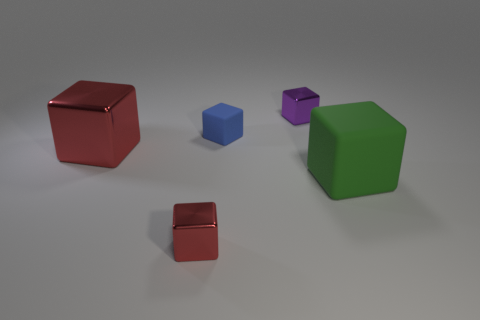Subtract all blue blocks. How many blocks are left? 4 Subtract all big green cubes. How many cubes are left? 4 Subtract all brown cubes. Subtract all yellow balls. How many cubes are left? 5 Add 3 tiny metal cubes. How many objects exist? 8 Add 4 blue matte things. How many blue matte things are left? 5 Add 3 small shiny cubes. How many small shiny cubes exist? 5 Subtract 0 green cylinders. How many objects are left? 5 Subtract all large red things. Subtract all small blue shiny objects. How many objects are left? 4 